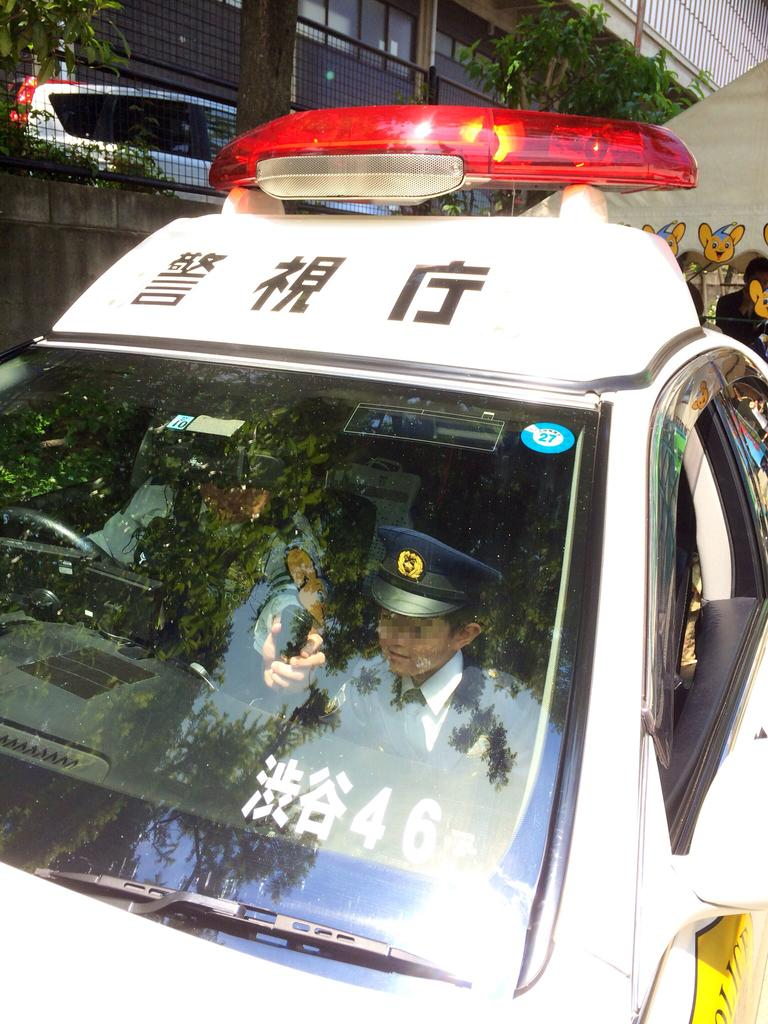What is happening in the image involving people? There are persons in a vehicle in the image. What can be seen in the background of the image? There is a car, a wall, trees, and a building in the background of the image. What type of brain can be seen in the image? There is no brain present in the image. Can you describe the observation skills of the persons in the vehicle? The image does not provide information about the observation skills of the persons in the vehicle. 